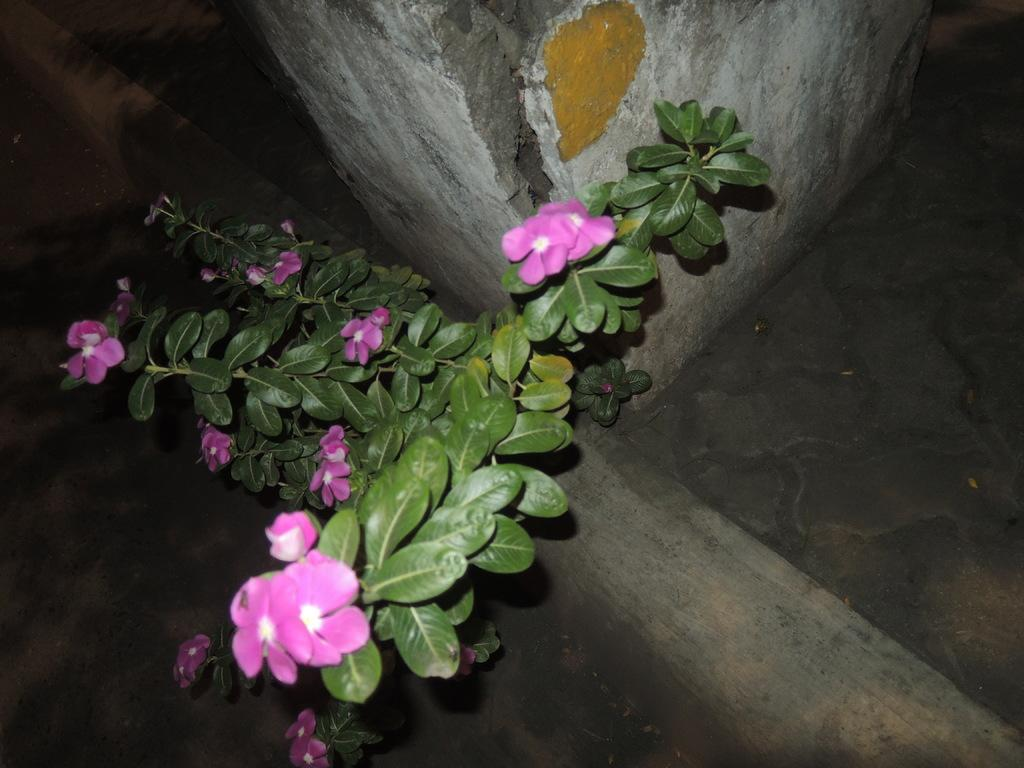What type of plant is visible in the image? There is a plant with leaves and flowers in the image. What can be seen in the background of the image? There is a wall in the background of the image. What is visible at the bottom of the image? There is a floor visible at the bottom of the image. What type of soup is being served on the linen in the image? There is no soup or linen present in the image; it features a plant with leaves and flowers in front of a wall. 